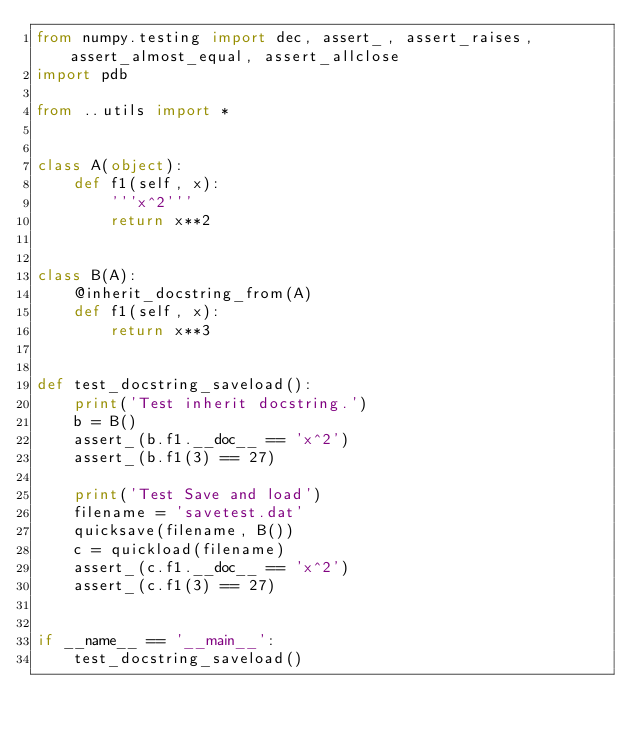<code> <loc_0><loc_0><loc_500><loc_500><_Python_>from numpy.testing import dec, assert_, assert_raises, assert_almost_equal, assert_allclose
import pdb

from ..utils import *


class A(object):
    def f1(self, x):
        '''x^2'''
        return x**2


class B(A):
    @inherit_docstring_from(A)
    def f1(self, x):
        return x**3


def test_docstring_saveload():
    print('Test inherit docstring.')
    b = B()
    assert_(b.f1.__doc__ == 'x^2')
    assert_(b.f1(3) == 27)

    print('Test Save and load')
    filename = 'savetest.dat'
    quicksave(filename, B())
    c = quickload(filename)
    assert_(c.f1.__doc__ == 'x^2')
    assert_(c.f1(3) == 27)


if __name__ == '__main__':
    test_docstring_saveload()
</code> 